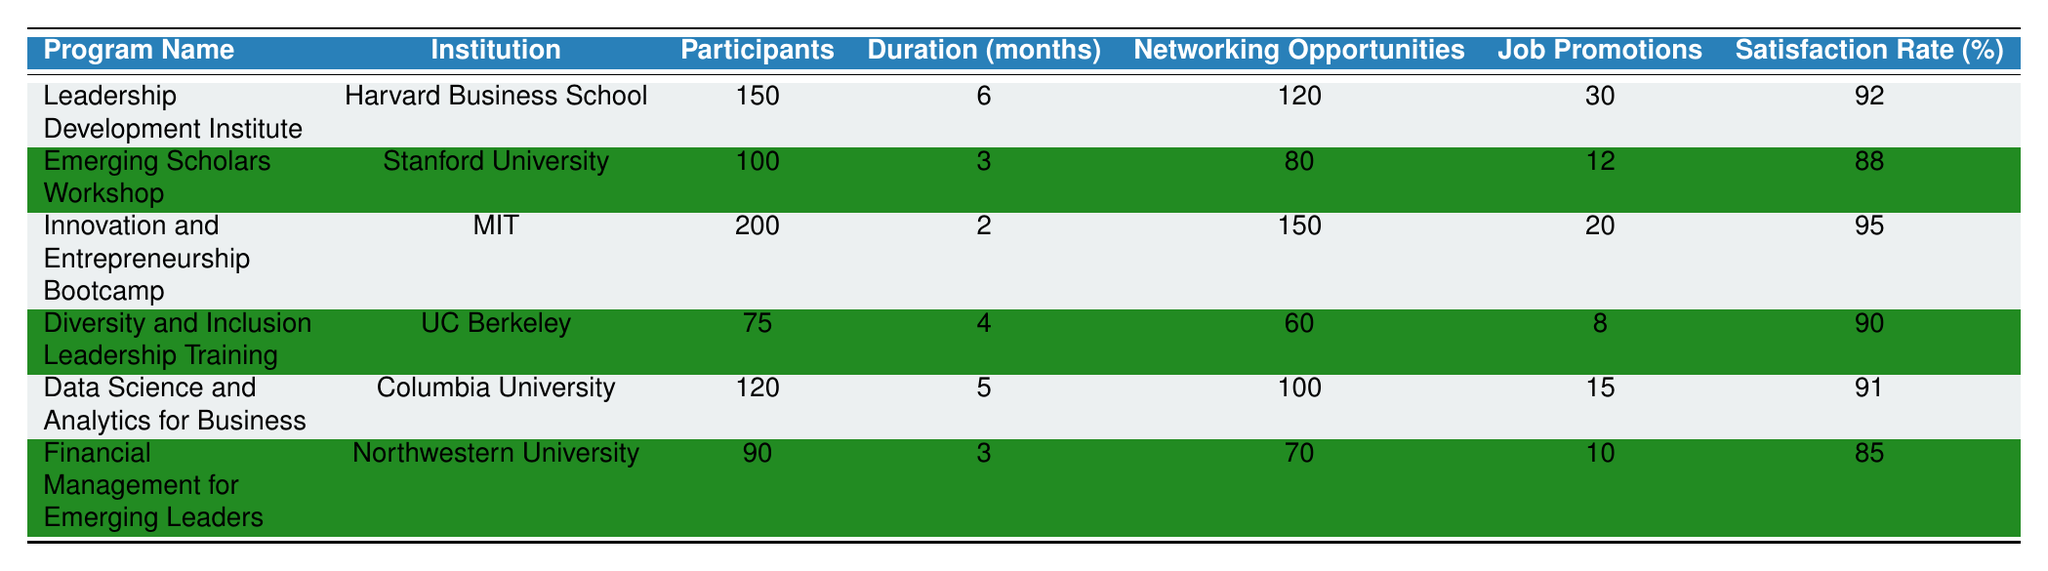What was the duration of the Innovation and Entrepreneurship Bootcamp? The table lists the duration of each program. For the Innovation and Entrepreneurship Bootcamp, the duration is stated as 2 months.
Answer: 2 months How many participants were in the Leadership Development Institute? Referring to the table, the number of participants in the Leadership Development Institute is specified as 150.
Answer: 150 What is the satisfaction rate for the Financial Management for Emerging Leaders program? Looking at the table, the satisfaction rate for the Financial Management for Emerging Leaders is marked as 85%.
Answer: 85% Which program had the highest satisfaction rate? To determine this, we compare the satisfaction rates in the table: 92%, 88%, 95%, 90%, 91%, and 85%. The highest rate is 95% for the Innovation and Entrepreneurship Bootcamp.
Answer: Innovation and Entrepreneurship Bootcamp How many job promotions resulted from the Diversity and Inclusion Leadership Training? The table indicates that the job promotions from the Diversity and Inclusion Leadership Training program are recorded as 8.
Answer: 8 What is the total number of participants across all programs? We sum the participants from each program: 150 + 100 + 200 + 75 + 120 + 90 = 735. Therefore, the total number of participants is 735.
Answer: 735 Which program provided the most networking opportunities? By examining the networking opportunities in the table, we see they are 120, 80, 150, 60, 100, and 70, respectively. The highest is 150 for the Innovation and Entrepreneurship Bootcamp.
Answer: Innovation and Entrepreneurship Bootcamp Is the average satisfaction rate of all listed programs above 90%? The satisfaction rates are 92, 88, 95, 90, 91, and 85. First, we calculate the average: (92 + 88 + 95 + 90 + 91 + 85) / 6 = 90.5. Since 90.5 is above 90%, the answer is yes.
Answer: Yes What percentage of participants in the Emerging Scholars Workshop received job promotions? There are 100 participants and 12 job promotions. To find the percentage, we use the formula (12 / 100) * 100 = 12%.
Answer: 12% Which two programs had a satisfaction rate below 90%? Checking the satisfaction rates: 92%, 88%, 95%, 90%, 91%, and 85%. The rates below 90% are 88% and 85% from the Emerging Scholars Workshop and Financial Management for Emerging Leaders, respectively.
Answer: Emerging Scholars Workshop and Financial Management for Emerging Leaders 